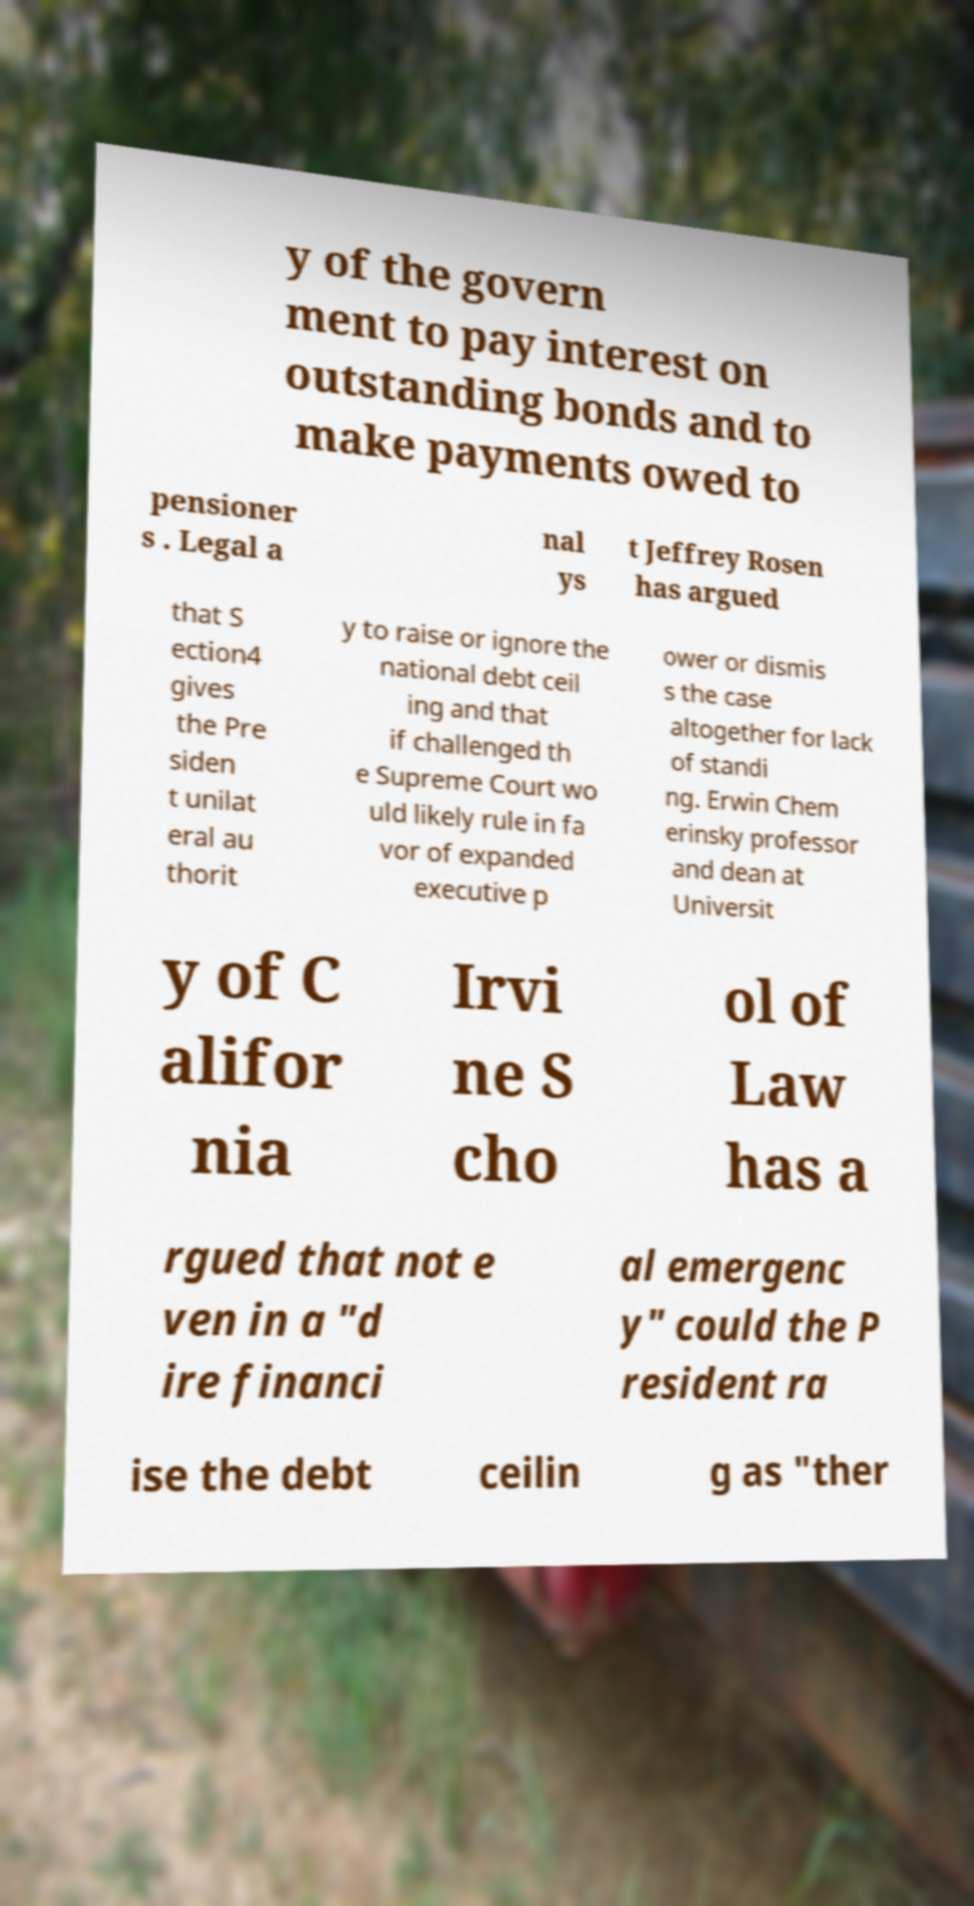Please identify and transcribe the text found in this image. y of the govern ment to pay interest on outstanding bonds and to make payments owed to pensioner s . Legal a nal ys t Jeffrey Rosen has argued that S ection4 gives the Pre siden t unilat eral au thorit y to raise or ignore the national debt ceil ing and that if challenged th e Supreme Court wo uld likely rule in fa vor of expanded executive p ower or dismis s the case altogether for lack of standi ng. Erwin Chem erinsky professor and dean at Universit y of C alifor nia Irvi ne S cho ol of Law has a rgued that not e ven in a "d ire financi al emergenc y" could the P resident ra ise the debt ceilin g as "ther 